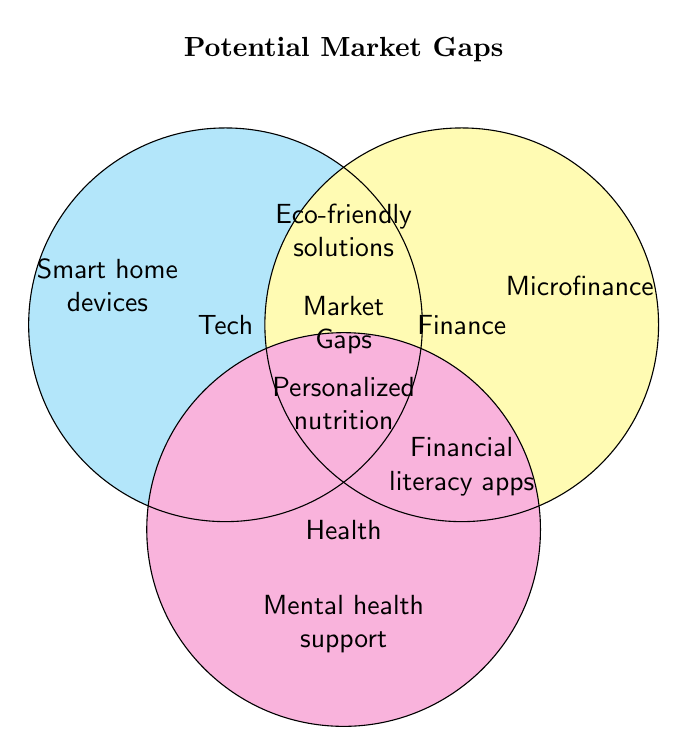What is the title of the figure? The title is generally located at the top of a diagram. In this case, it's clearly labeled in bold text above the Venn Diagram.
Answer: Potential Market Gaps Which category overlaps with "Mental health support"? "Mental health support" is located within the circle labeled "Health." The overlap indicates that mental health support is associated with the health market.
Answer: Health List all gaps identified in the Tech category. The circle labeled "Tech" lists "Smart home devices" and "Eco-friendly solutions." These are the market gaps for the Tech category.
Answer: Smart home devices, Eco-friendly solutions Which market gap appears in the intersection of Tech and Finance? Observing where the circles for "Tech" and "Finance" overlap shows that "Eco-friendly solutions" are positioned in that intersection.
Answer: Eco-friendly solutions How many distinct market gaps are shown in the diagram? Count all the text entries inside and outside the circles in the diagram. There are seven distinct market gaps listed: Smart home devices, Eco-friendly solutions, Microfinance, Financial literacy apps, Market gaps, Personalized nutrition, and Mental health support.
Answer: Seven 